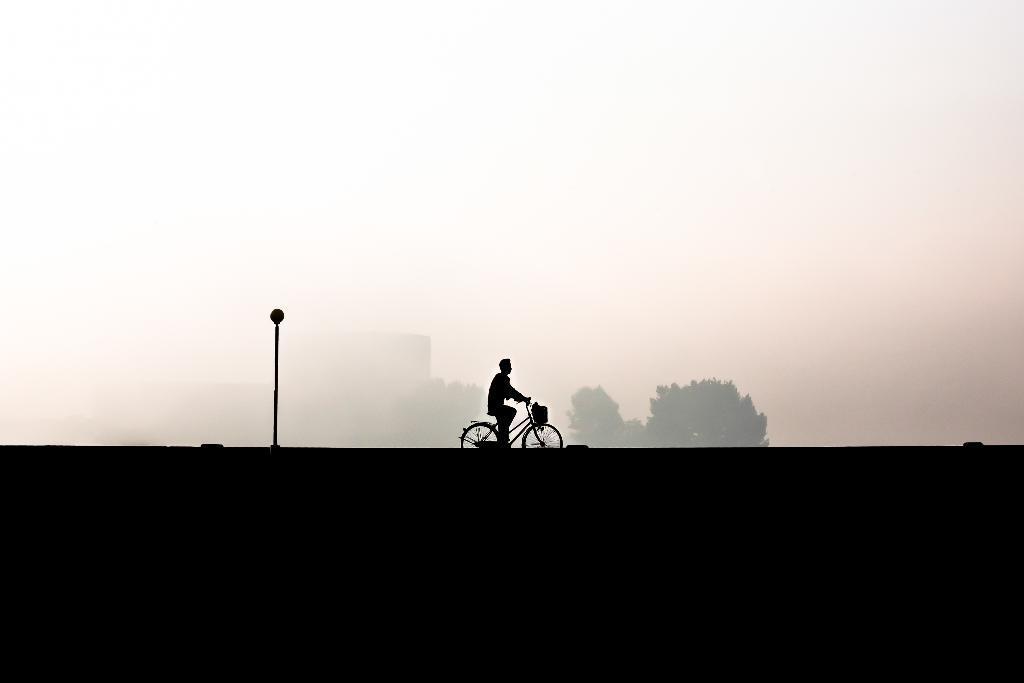Could you give a brief overview of what you see in this image? In the middle of the picture, we see the man riding the bicycle. Behind him, we see a pole. At the bottom, it is black in color. In the background, we see the trees and a building. At the top, we see the sky, which is covered with the fog. 